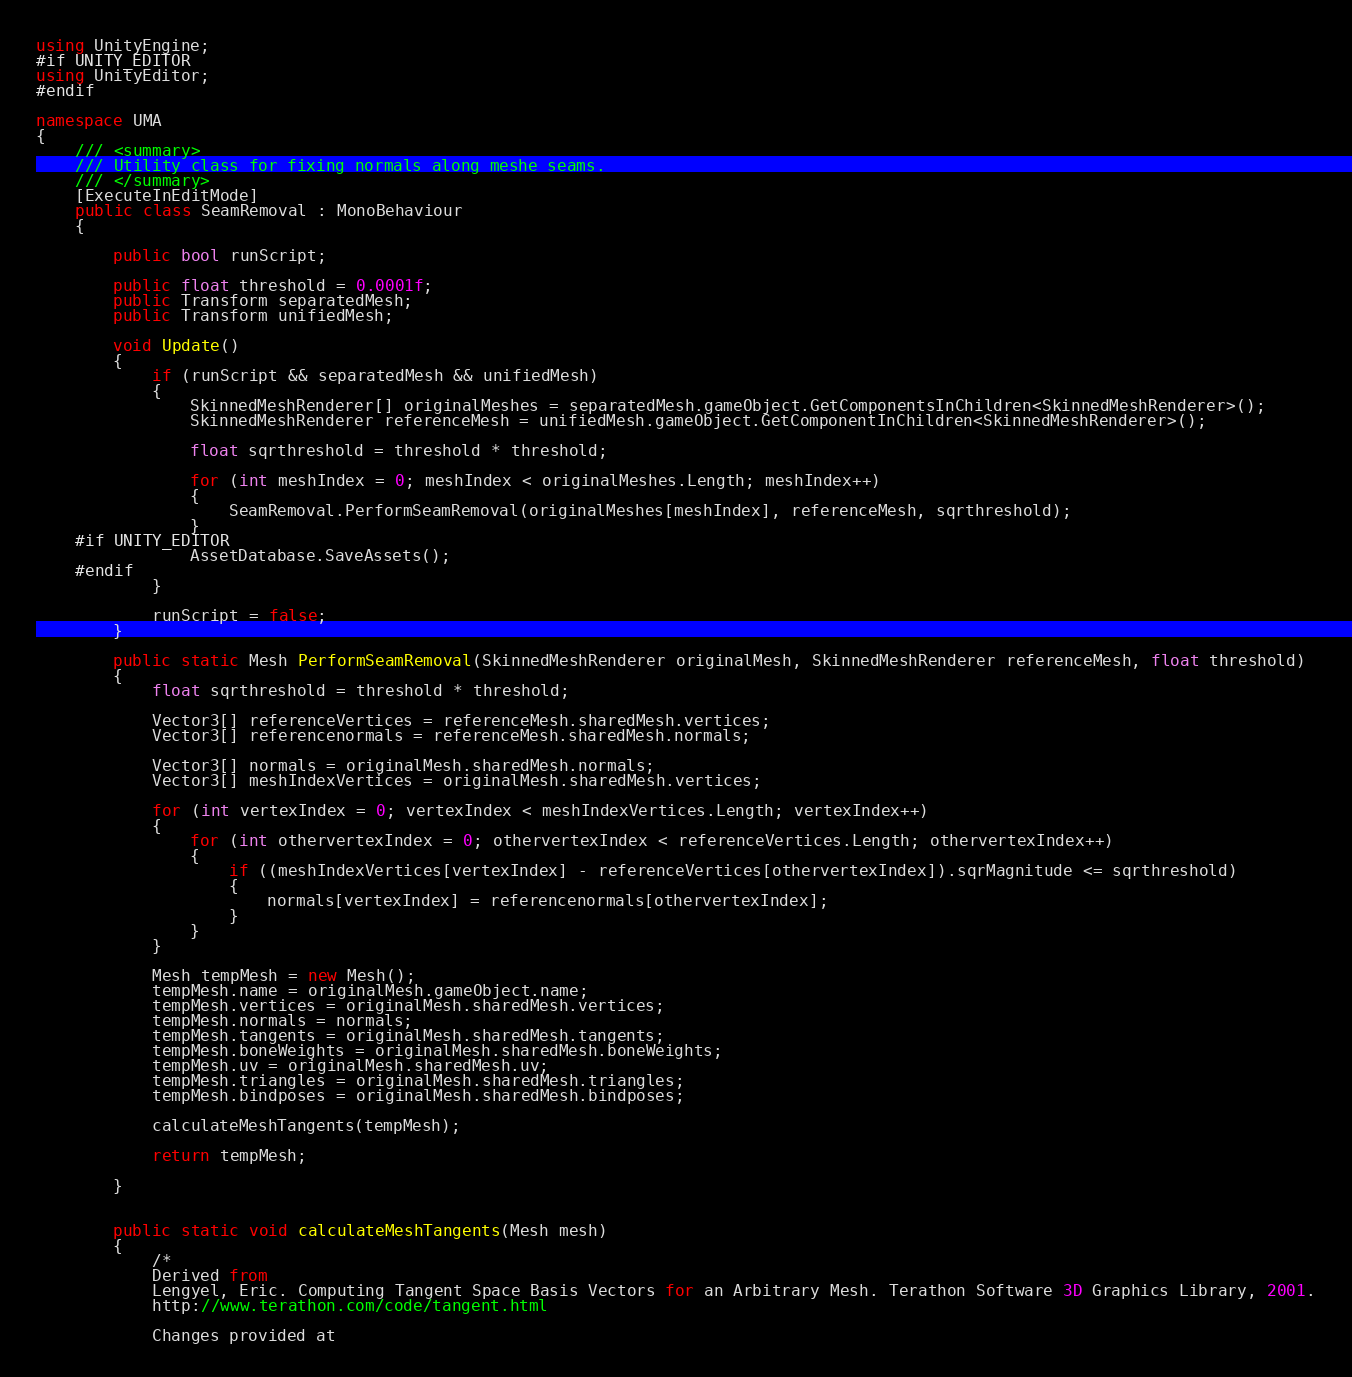<code> <loc_0><loc_0><loc_500><loc_500><_C#_>using UnityEngine;
#if UNITY_EDITOR
using UnityEditor;
#endif

namespace UMA
{
	/// <summary>
	/// Utility class for fixing normals along meshe seams.
	/// </summary>
	[ExecuteInEditMode]
	public class SeamRemoval : MonoBehaviour
	{

	    public bool runScript;

	    public float threshold = 0.0001f;
	    public Transform separatedMesh;
	    public Transform unifiedMesh;

	    void Update()
	    {
	        if (runScript && separatedMesh && unifiedMesh)
	        {
	            SkinnedMeshRenderer[] originalMeshes = separatedMesh.gameObject.GetComponentsInChildren<SkinnedMeshRenderer>();
	            SkinnedMeshRenderer referenceMesh = unifiedMesh.gameObject.GetComponentInChildren<SkinnedMeshRenderer>();

	            float sqrthreshold = threshold * threshold;

	            for (int meshIndex = 0; meshIndex < originalMeshes.Length; meshIndex++)
	            {
	                SeamRemoval.PerformSeamRemoval(originalMeshes[meshIndex], referenceMesh, sqrthreshold);
	            }
	#if UNITY_EDITOR
	            AssetDatabase.SaveAssets();
	#endif
	        }

	        runScript = false;
	    }

	    public static Mesh PerformSeamRemoval(SkinnedMeshRenderer originalMesh, SkinnedMeshRenderer referenceMesh, float threshold)
	    {
			float sqrthreshold = threshold * threshold;
			
	        Vector3[] referenceVertices = referenceMesh.sharedMesh.vertices;
	        Vector3[] referencenormals = referenceMesh.sharedMesh.normals;

	        Vector3[] normals = originalMesh.sharedMesh.normals;
	        Vector3[] meshIndexVertices = originalMesh.sharedMesh.vertices;

	        for (int vertexIndex = 0; vertexIndex < meshIndexVertices.Length; vertexIndex++)
	        {
	            for (int othervertexIndex = 0; othervertexIndex < referenceVertices.Length; othervertexIndex++)
	            {
	                if ((meshIndexVertices[vertexIndex] - referenceVertices[othervertexIndex]).sqrMagnitude <= sqrthreshold)
	                {
						normals[vertexIndex] = referencenormals[othervertexIndex];
	                }
	            }
	        }		
				
			Mesh tempMesh = new Mesh();
			tempMesh.name = originalMesh.gameObject.name;
			tempMesh.vertices = originalMesh.sharedMesh.vertices;
			tempMesh.normals = normals;
			tempMesh.tangents = originalMesh.sharedMesh.tangents;
			tempMesh.boneWeights = originalMesh.sharedMesh.boneWeights;
			tempMesh.uv = originalMesh.sharedMesh.uv;
			tempMesh.triangles = originalMesh.sharedMesh.triangles;
			tempMesh.bindposes = originalMesh.sharedMesh.bindposes;
			
			calculateMeshTangents(tempMesh);
			
	        return tempMesh;

	    }
		

		public static void calculateMeshTangents(Mesh mesh)
		{
			/*
			Derived from
			Lengyel, Eric. Computing Tangent Space Basis Vectors for an Arbitrary Mesh. Terathon Software 3D Graphics Library, 2001.
			http://www.terathon.com/code/tangent.html
			
			Changes provided at</code> 